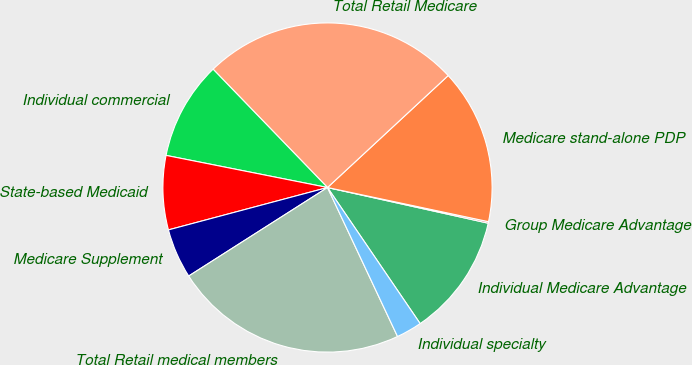Convert chart. <chart><loc_0><loc_0><loc_500><loc_500><pie_chart><fcel>Individual Medicare Advantage<fcel>Group Medicare Advantage<fcel>Medicare stand-alone PDP<fcel>Total Retail Medicare<fcel>Individual commercial<fcel>State-based Medicaid<fcel>Medicare Supplement<fcel>Total Retail medical members<fcel>Individual specialty<nl><fcel>12.01%<fcel>0.15%<fcel>15.23%<fcel>25.33%<fcel>9.64%<fcel>7.27%<fcel>4.89%<fcel>22.96%<fcel>2.52%<nl></chart> 